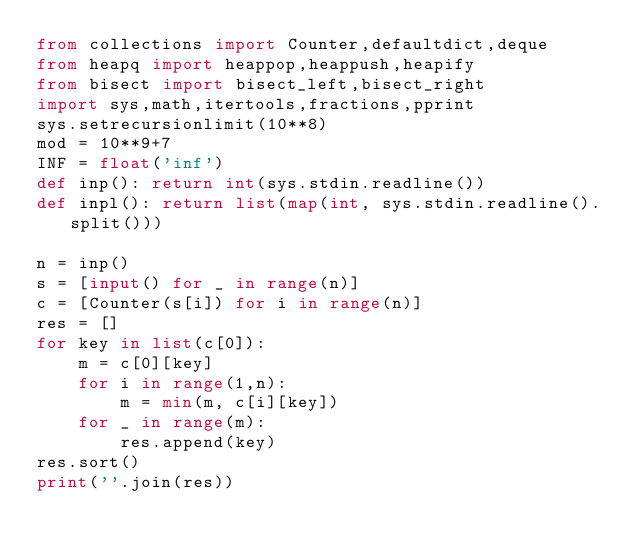Convert code to text. <code><loc_0><loc_0><loc_500><loc_500><_Python_>from collections import Counter,defaultdict,deque
from heapq import heappop,heappush,heapify
from bisect import bisect_left,bisect_right 
import sys,math,itertools,fractions,pprint
sys.setrecursionlimit(10**8)
mod = 10**9+7
INF = float('inf')
def inp(): return int(sys.stdin.readline())
def inpl(): return list(map(int, sys.stdin.readline().split()))

n = inp()
s = [input() for _ in range(n)]
c = [Counter(s[i]) for i in range(n)]
res = []
for key in list(c[0]):
    m = c[0][key]
    for i in range(1,n):
        m = min(m, c[i][key])
    for _ in range(m):
        res.append(key)
res.sort()
print(''.join(res))</code> 